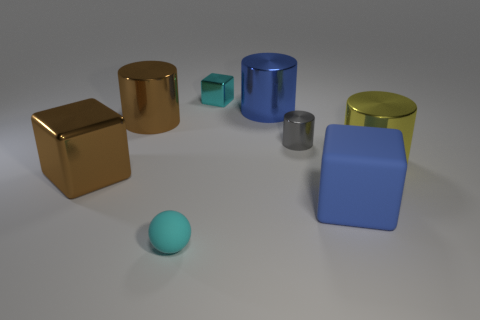Add 1 large blue metal things. How many objects exist? 9 Subtract all balls. How many objects are left? 7 Add 1 tiny gray blocks. How many tiny gray blocks exist? 1 Subtract 0 red balls. How many objects are left? 8 Subtract all cyan metallic things. Subtract all big matte objects. How many objects are left? 6 Add 5 blue blocks. How many blue blocks are left? 6 